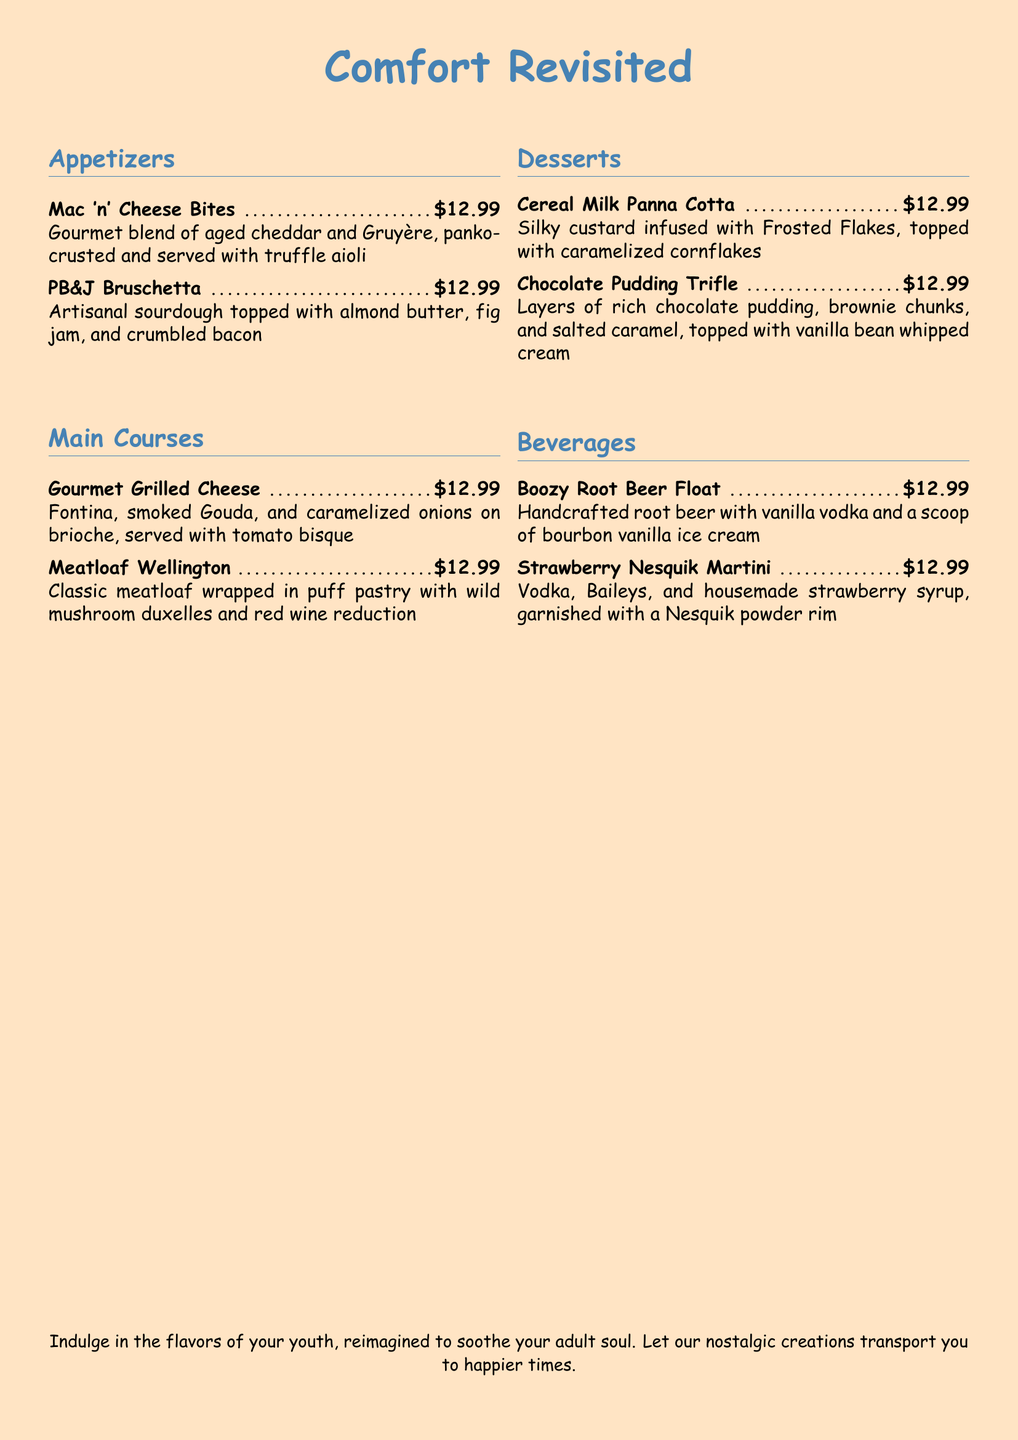What are the appetizers offered? The section lists the appetizers, which include "Mac 'n' Cheese Bites" and "PB&J Bruschetta."
Answer: Mac 'n' Cheese Bites, PB&J Bruschetta How much does the Gourmet Grilled Cheese cost? The price for the Gourmet Grilled Cheese is specified in the menu item details.
Answer: $12.99 What is the main ingredient in the Cereal Milk Panna Cotta? The main flavor ingredient of the Cereal Milk Panna Cotta is mentioned in the description.
Answer: Frosted Flakes Which dessert includes brownie chunks? The Chocolate Pudding Trifle is the only dessert that includes brownie chunks.
Answer: Chocolate Pudding Trifle What type of bread is used for the Gourmet Grilled Cheese? The document specifies the type of bread used in the description of the Gourmet Grilled Cheese.
Answer: Brioche What is the theme of the restaurant menu? The title and the closing statement reflect the overall theme of the menu, indicating it focuses on nostalgia.
Answer: Nostalgic favorites How many main courses are listed? The number of main courses can be counted from the menu section.
Answer: 2 What unique ingredient is in the Boozy Root Beer Float? The menu item description highlights a specific unique ingredient used in the beverage.
Answer: Vanilla vodka 